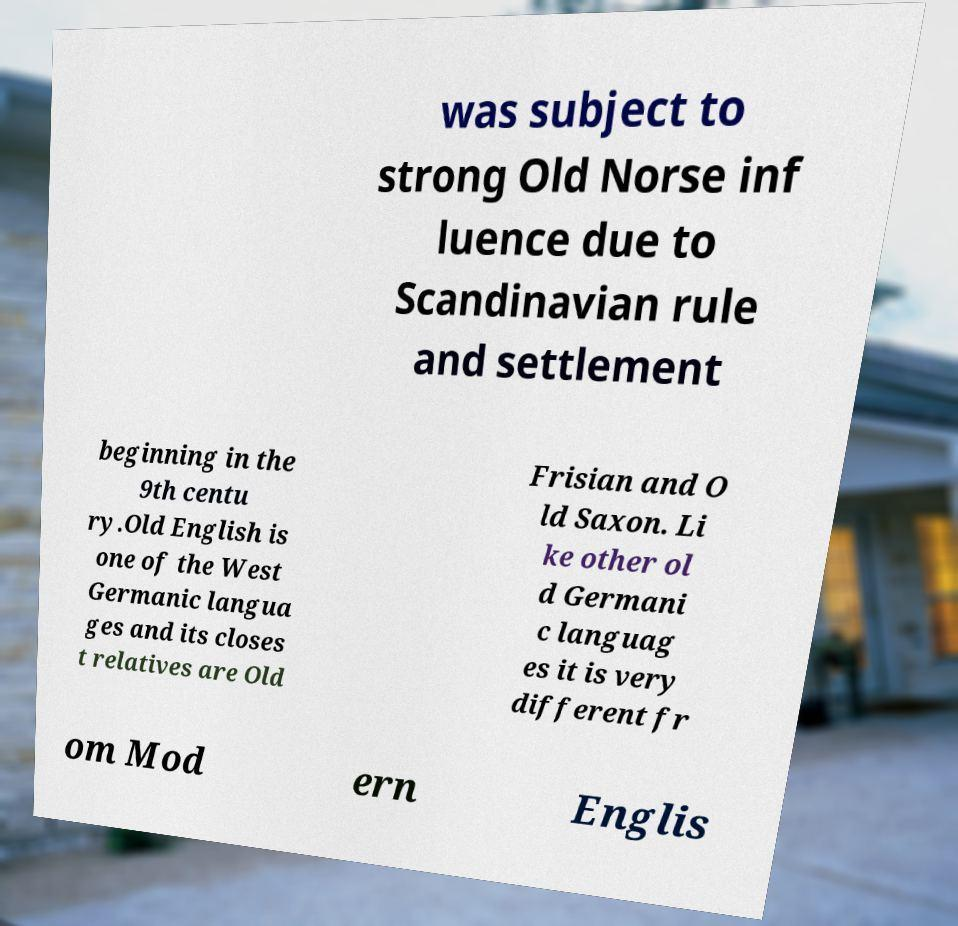There's text embedded in this image that I need extracted. Can you transcribe it verbatim? was subject to strong Old Norse inf luence due to Scandinavian rule and settlement beginning in the 9th centu ry.Old English is one of the West Germanic langua ges and its closes t relatives are Old Frisian and O ld Saxon. Li ke other ol d Germani c languag es it is very different fr om Mod ern Englis 